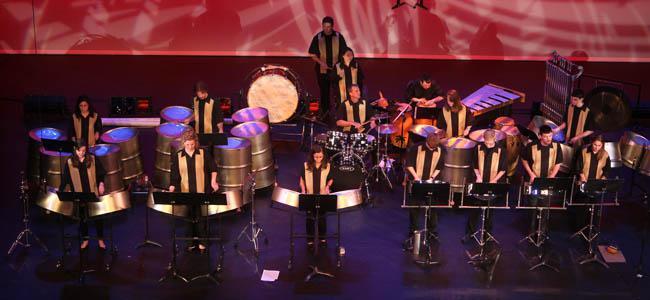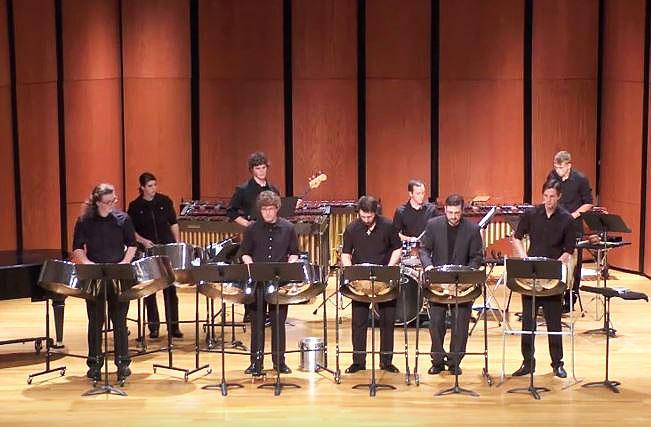The first image is the image on the left, the second image is the image on the right. Given the left and right images, does the statement "All of the drummers in the image on the left are wearing purple shirts." hold true? Answer yes or no. No. The first image is the image on the left, the second image is the image on the right. For the images displayed, is the sentence "The left image shows a group of musicians in black pants and violet-blue short-sleeved shirts standing in front of cylindrical drums." factually correct? Answer yes or no. No. 